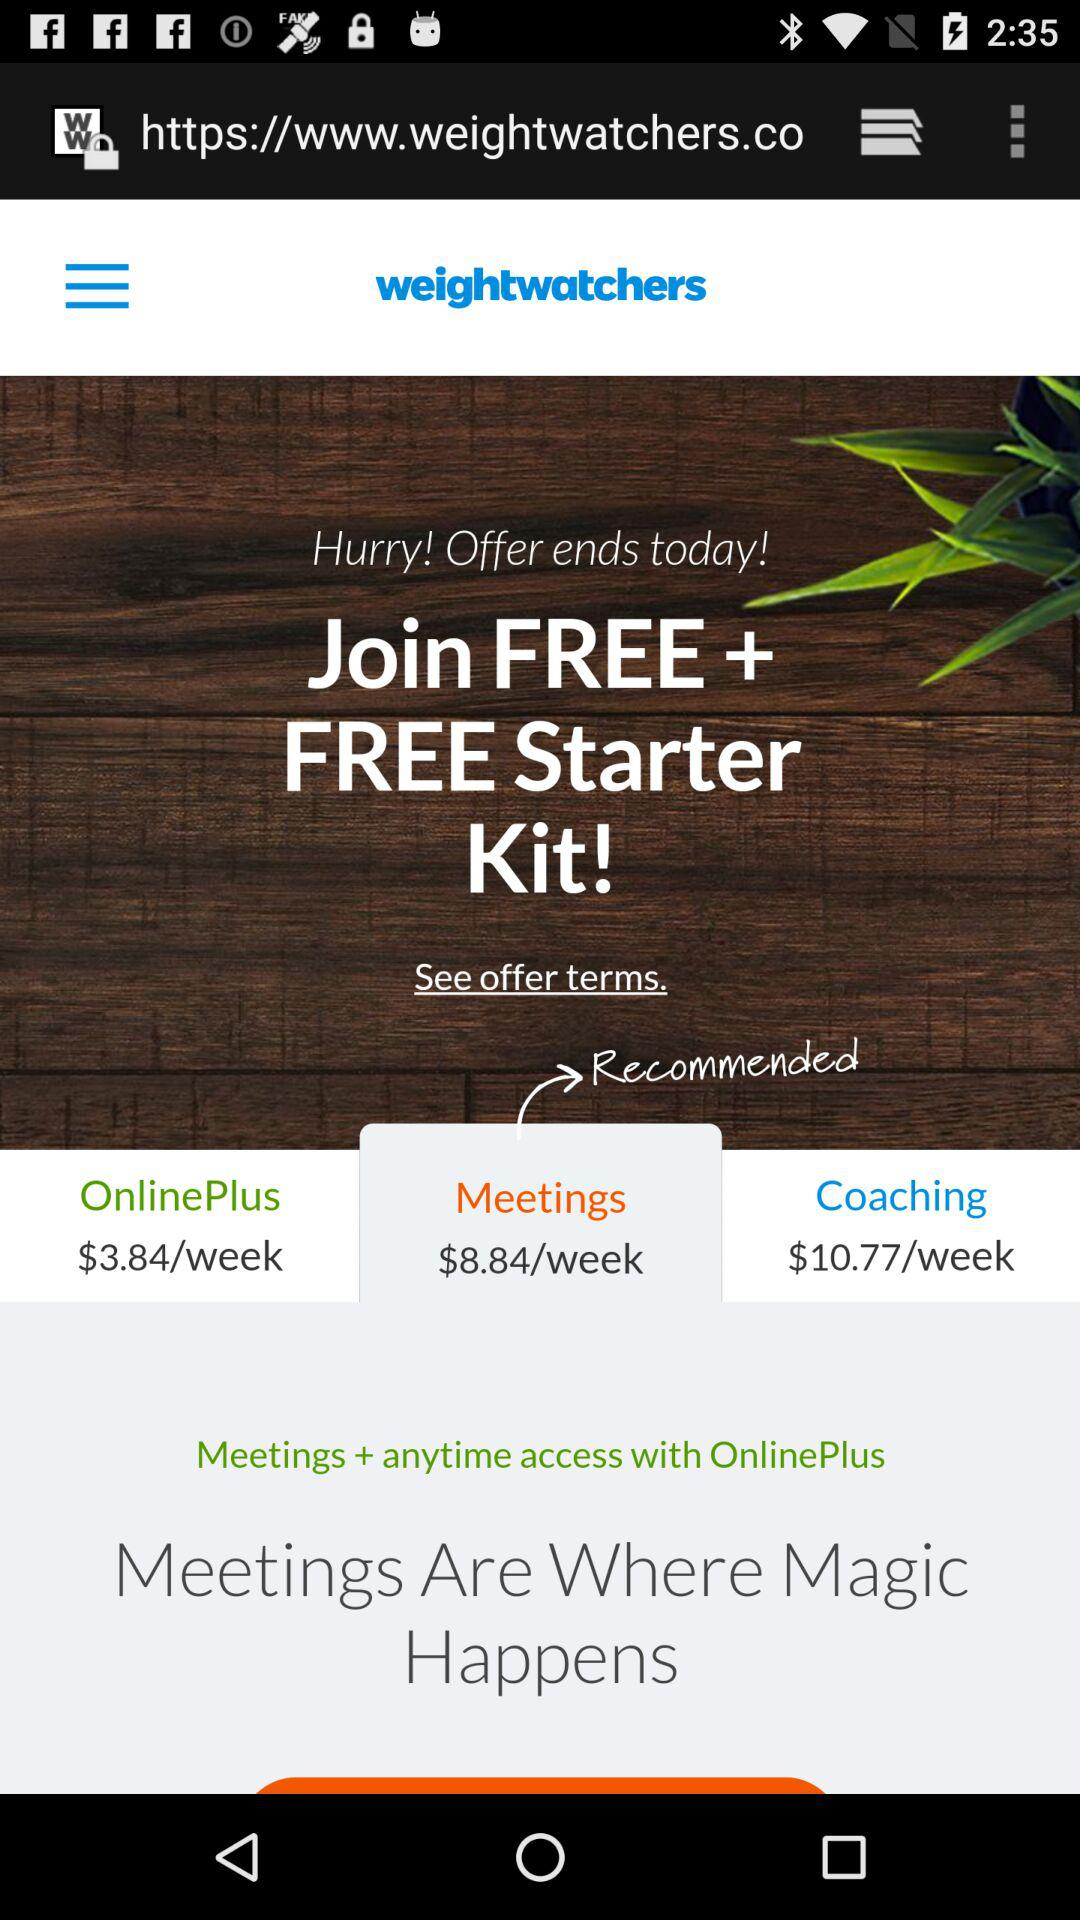What is the name of the application? The name of the application is "weightwatchers". 